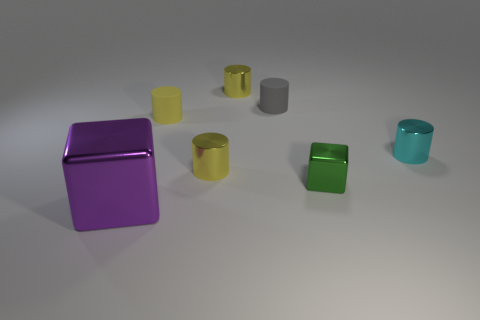How many balls are either large objects or tiny yellow objects?
Your answer should be compact. 0. What number of metallic things are on the right side of the purple cube and in front of the tiny yellow matte cylinder?
Offer a very short reply. 3. Is the number of small cyan cylinders that are behind the small shiny cube the same as the number of cyan shiny things that are in front of the small cyan metallic object?
Your response must be concise. No. Is the shape of the metal object to the right of the small shiny cube the same as  the small yellow rubber thing?
Offer a very short reply. Yes. There is a large purple thing in front of the cube that is right of the block to the left of the tiny green cube; what shape is it?
Offer a terse response. Cube. The small object that is both in front of the gray matte thing and behind the cyan object is made of what material?
Provide a succinct answer. Rubber. Are there fewer red shiny cylinders than yellow metal objects?
Your response must be concise. Yes. Does the gray rubber thing have the same shape as the metal thing that is in front of the small green metal cube?
Offer a terse response. No. Is the size of the metallic cube right of the yellow matte object the same as the tiny cyan thing?
Offer a terse response. Yes. What is the shape of the gray object that is the same size as the cyan metal cylinder?
Your answer should be compact. Cylinder. 